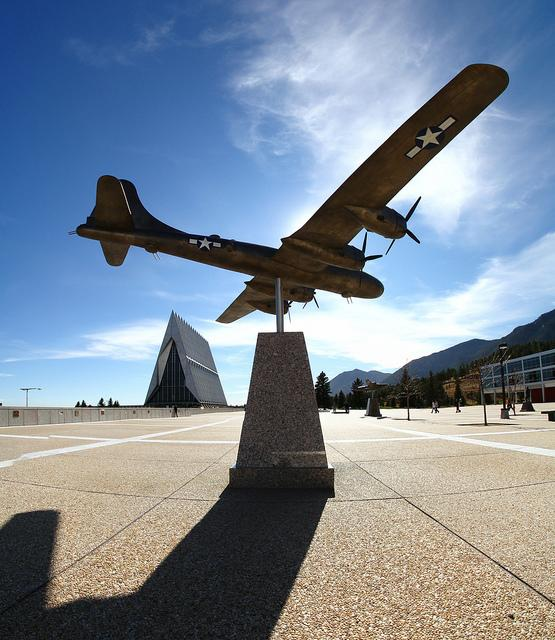How fast is this plane flying now?

Choices:
A) zero mph
B) 100 mph
C) mach 5
D) 250 mph zero mph 